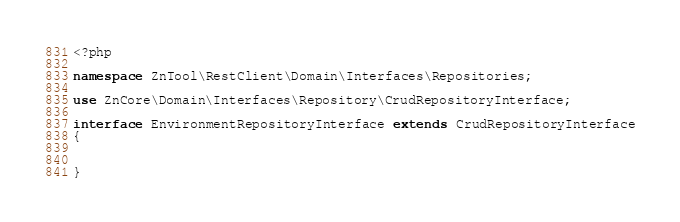Convert code to text. <code><loc_0><loc_0><loc_500><loc_500><_PHP_><?php

namespace ZnTool\RestClient\Domain\Interfaces\Repositories;

use ZnCore\Domain\Interfaces\Repository\CrudRepositoryInterface;

interface EnvironmentRepositoryInterface extends CrudRepositoryInterface
{


}

</code> 